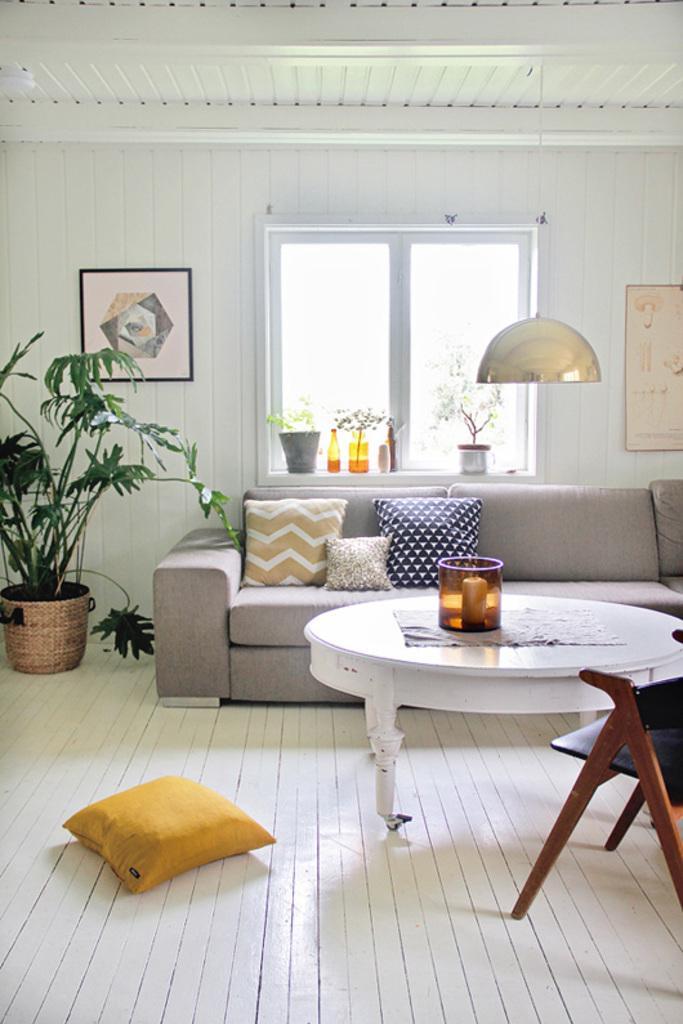Could you give a brief overview of what you see in this image? In this image there is a floor. There is a table. There is a chair. There is sofa. We can see the pillows. There is a wall with glass window. There are pots. There are sceneries on the walls. 